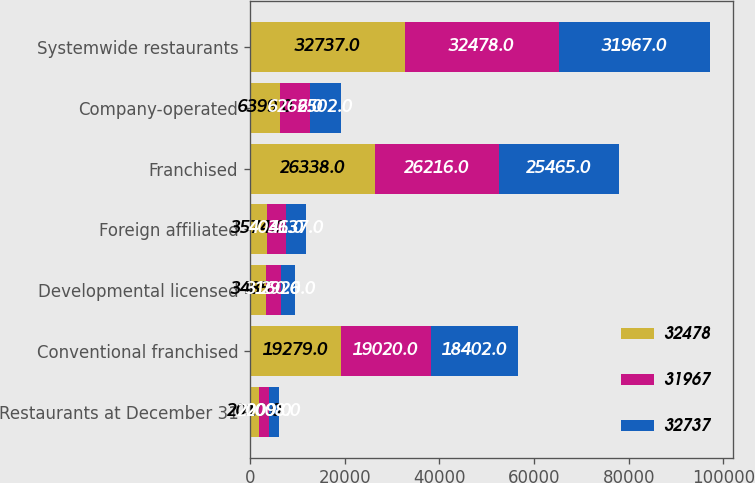Convert chart to OTSL. <chart><loc_0><loc_0><loc_500><loc_500><stacked_bar_chart><ecel><fcel>Restaurants at December 31<fcel>Conventional franchised<fcel>Developmental licensed<fcel>Foreign affiliated<fcel>Franchised<fcel>Company-operated<fcel>Systemwide restaurants<nl><fcel>32478<fcel>2010<fcel>19279<fcel>3485<fcel>3574<fcel>26338<fcel>6399<fcel>32737<nl><fcel>31967<fcel>2009<fcel>19020<fcel>3160<fcel>4036<fcel>26216<fcel>6262<fcel>32478<nl><fcel>32737<fcel>2008<fcel>18402<fcel>2926<fcel>4137<fcel>25465<fcel>6502<fcel>31967<nl></chart> 